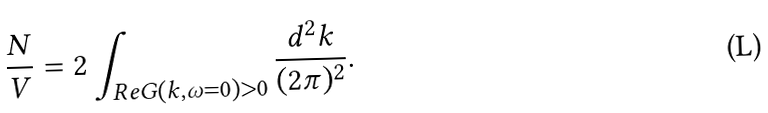Convert formula to latex. <formula><loc_0><loc_0><loc_500><loc_500>\frac { N } { V } = 2 \int _ { { R e } G ( { k } , \omega = 0 ) > 0 } \frac { d ^ { 2 } { k } } { ( 2 \pi ) ^ { 2 } } .</formula> 